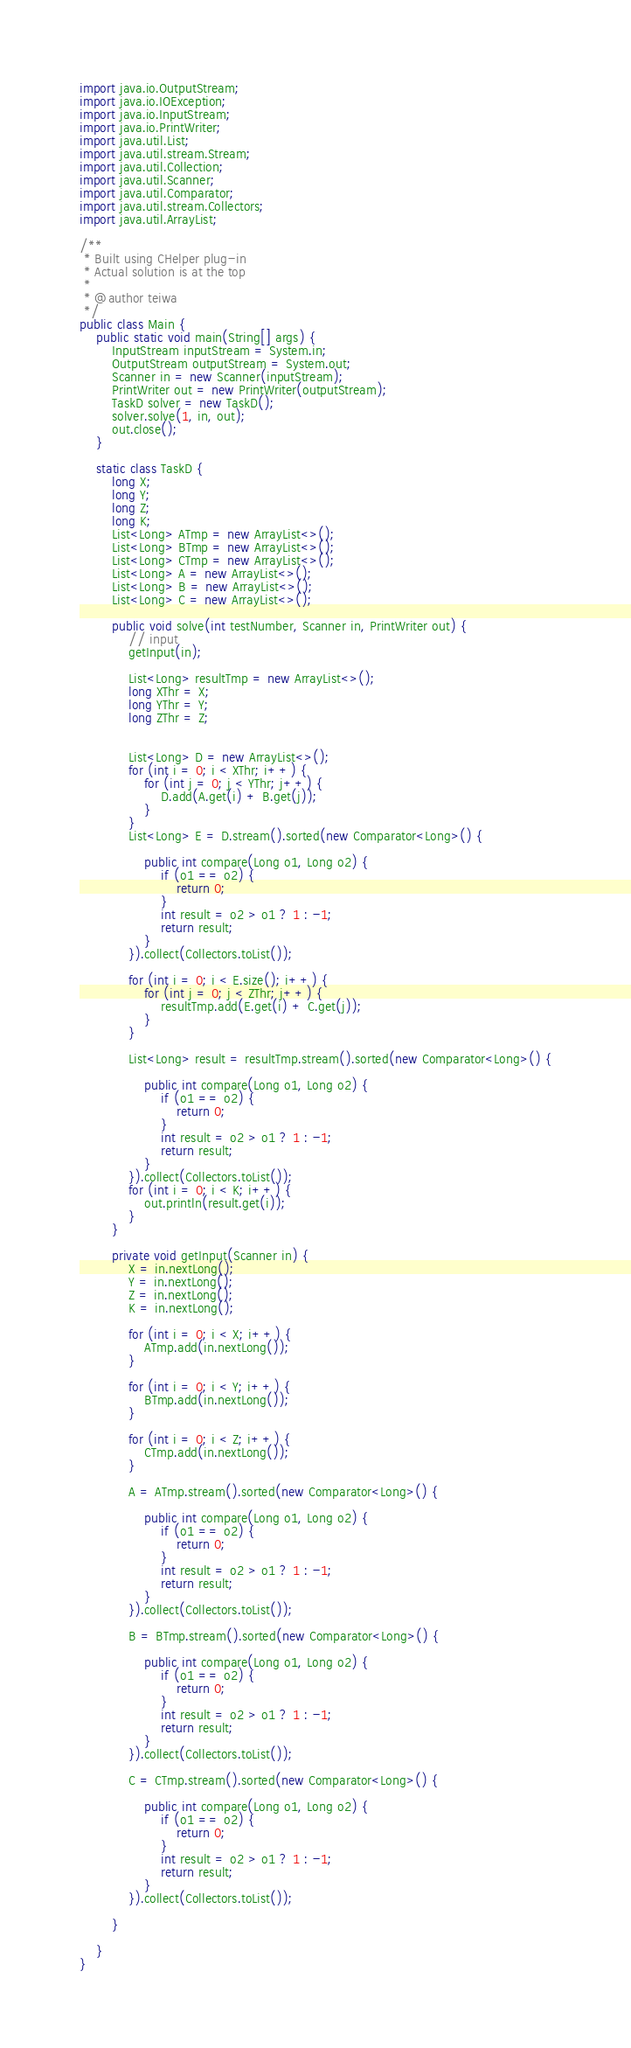Convert code to text. <code><loc_0><loc_0><loc_500><loc_500><_Java_>import java.io.OutputStream;
import java.io.IOException;
import java.io.InputStream;
import java.io.PrintWriter;
import java.util.List;
import java.util.stream.Stream;
import java.util.Collection;
import java.util.Scanner;
import java.util.Comparator;
import java.util.stream.Collectors;
import java.util.ArrayList;

/**
 * Built using CHelper plug-in
 * Actual solution is at the top
 *
 * @author teiwa
 */
public class Main {
    public static void main(String[] args) {
        InputStream inputStream = System.in;
        OutputStream outputStream = System.out;
        Scanner in = new Scanner(inputStream);
        PrintWriter out = new PrintWriter(outputStream);
        TaskD solver = new TaskD();
        solver.solve(1, in, out);
        out.close();
    }

    static class TaskD {
        long X;
        long Y;
        long Z;
        long K;
        List<Long> ATmp = new ArrayList<>();
        List<Long> BTmp = new ArrayList<>();
        List<Long> CTmp = new ArrayList<>();
        List<Long> A = new ArrayList<>();
        List<Long> B = new ArrayList<>();
        List<Long> C = new ArrayList<>();

        public void solve(int testNumber, Scanner in, PrintWriter out) {
            // input
            getInput(in);

            List<Long> resultTmp = new ArrayList<>();
            long XThr = X;
            long YThr = Y;
            long ZThr = Z;


            List<Long> D = new ArrayList<>();
            for (int i = 0; i < XThr; i++) {
                for (int j = 0; j < YThr; j++) {
                    D.add(A.get(i) + B.get(j));
                }
            }
            List<Long> E = D.stream().sorted(new Comparator<Long>() {

                public int compare(Long o1, Long o2) {
                    if (o1 == o2) {
                        return 0;
                    }
                    int result = o2 > o1 ? 1 : -1;
                    return result;
                }
            }).collect(Collectors.toList());

            for (int i = 0; i < E.size(); i++) {
                for (int j = 0; j < ZThr; j++) {
                    resultTmp.add(E.get(i) + C.get(j));
                }
            }

            List<Long> result = resultTmp.stream().sorted(new Comparator<Long>() {

                public int compare(Long o1, Long o2) {
                    if (o1 == o2) {
                        return 0;
                    }
                    int result = o2 > o1 ? 1 : -1;
                    return result;
                }
            }).collect(Collectors.toList());
            for (int i = 0; i < K; i++) {
                out.println(result.get(i));
            }
        }

        private void getInput(Scanner in) {
            X = in.nextLong();
            Y = in.nextLong();
            Z = in.nextLong();
            K = in.nextLong();

            for (int i = 0; i < X; i++) {
                ATmp.add(in.nextLong());
            }

            for (int i = 0; i < Y; i++) {
                BTmp.add(in.nextLong());
            }

            for (int i = 0; i < Z; i++) {
                CTmp.add(in.nextLong());
            }

            A = ATmp.stream().sorted(new Comparator<Long>() {

                public int compare(Long o1, Long o2) {
                    if (o1 == o2) {
                        return 0;
                    }
                    int result = o2 > o1 ? 1 : -1;
                    return result;
                }
            }).collect(Collectors.toList());

            B = BTmp.stream().sorted(new Comparator<Long>() {

                public int compare(Long o1, Long o2) {
                    if (o1 == o2) {
                        return 0;
                    }
                    int result = o2 > o1 ? 1 : -1;
                    return result;
                }
            }).collect(Collectors.toList());

            C = CTmp.stream().sorted(new Comparator<Long>() {

                public int compare(Long o1, Long o2) {
                    if (o1 == o2) {
                        return 0;
                    }
                    int result = o2 > o1 ? 1 : -1;
                    return result;
                }
            }).collect(Collectors.toList());

        }

    }
}

</code> 